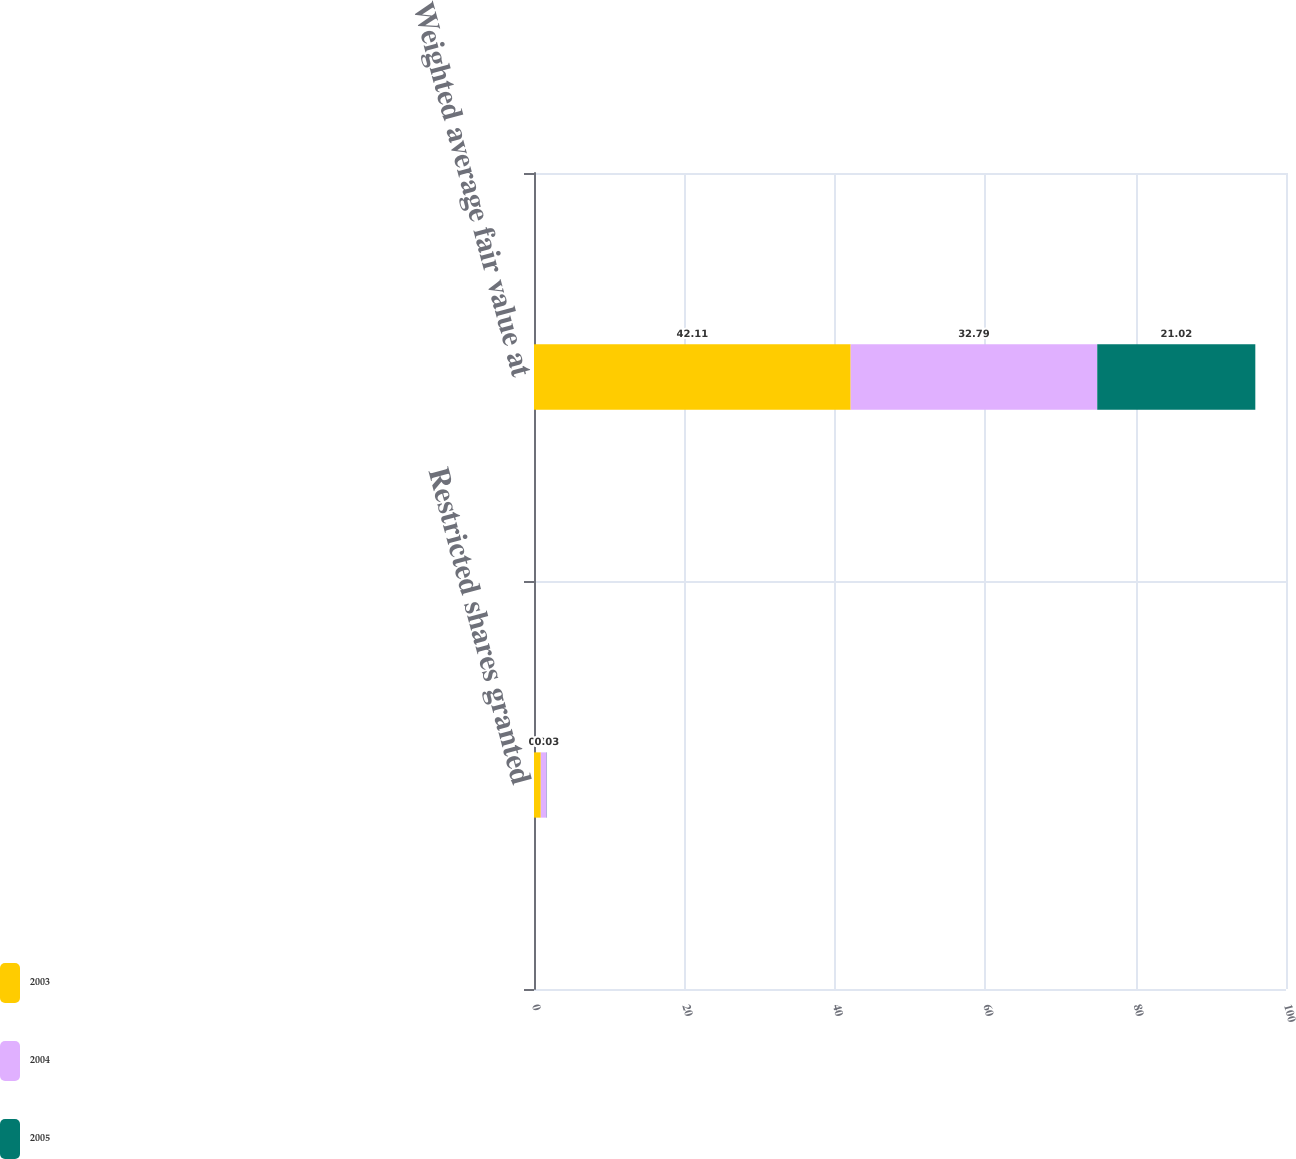Convert chart to OTSL. <chart><loc_0><loc_0><loc_500><loc_500><stacked_bar_chart><ecel><fcel>Restricted shares granted<fcel>Weighted average fair value at<nl><fcel>2003<fcel>0.9<fcel>42.11<nl><fcel>2004<fcel>0.8<fcel>32.79<nl><fcel>2005<fcel>0.03<fcel>21.02<nl></chart> 